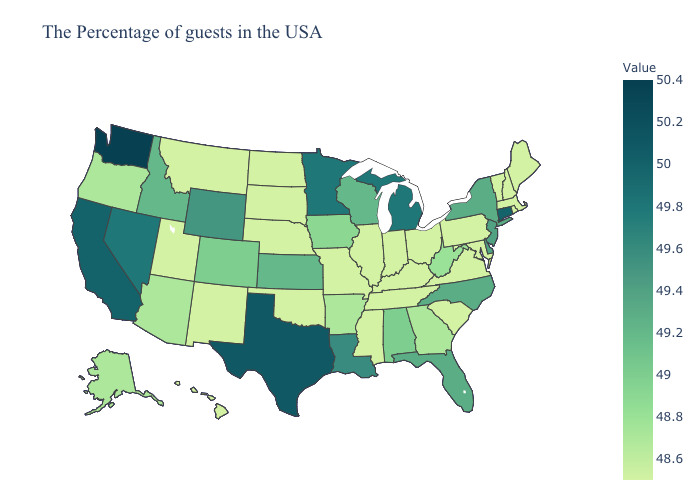Does New Jersey have the lowest value in the USA?
Keep it brief. No. Does Connecticut have the lowest value in the USA?
Give a very brief answer. No. Which states have the highest value in the USA?
Concise answer only. Washington. Does Louisiana have the lowest value in the USA?
Give a very brief answer. No. Does Georgia have the highest value in the USA?
Short answer required. No. Does Montana have a lower value than Texas?
Keep it brief. Yes. Which states hav the highest value in the Northeast?
Short answer required. Connecticut. Which states have the lowest value in the USA?
Quick response, please. Maine, Massachusetts, Rhode Island, New Hampshire, Vermont, Maryland, Pennsylvania, Virginia, South Carolina, Ohio, Kentucky, Indiana, Tennessee, Illinois, Mississippi, Missouri, Nebraska, Oklahoma, South Dakota, North Dakota, New Mexico, Utah, Montana, Hawaii. 